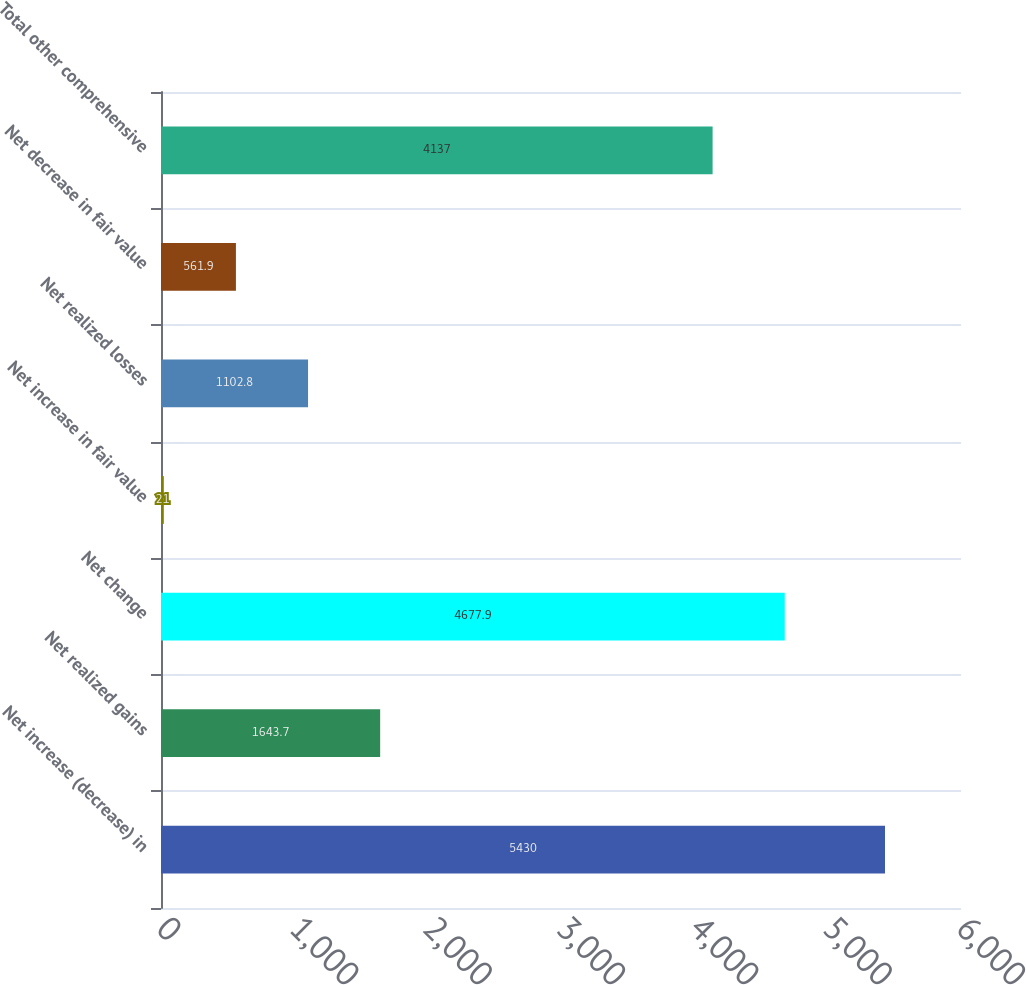<chart> <loc_0><loc_0><loc_500><loc_500><bar_chart><fcel>Net increase (decrease) in<fcel>Net realized gains<fcel>Net change<fcel>Net increase in fair value<fcel>Net realized losses<fcel>Net decrease in fair value<fcel>Total other comprehensive<nl><fcel>5430<fcel>1643.7<fcel>4677.9<fcel>21<fcel>1102.8<fcel>561.9<fcel>4137<nl></chart> 